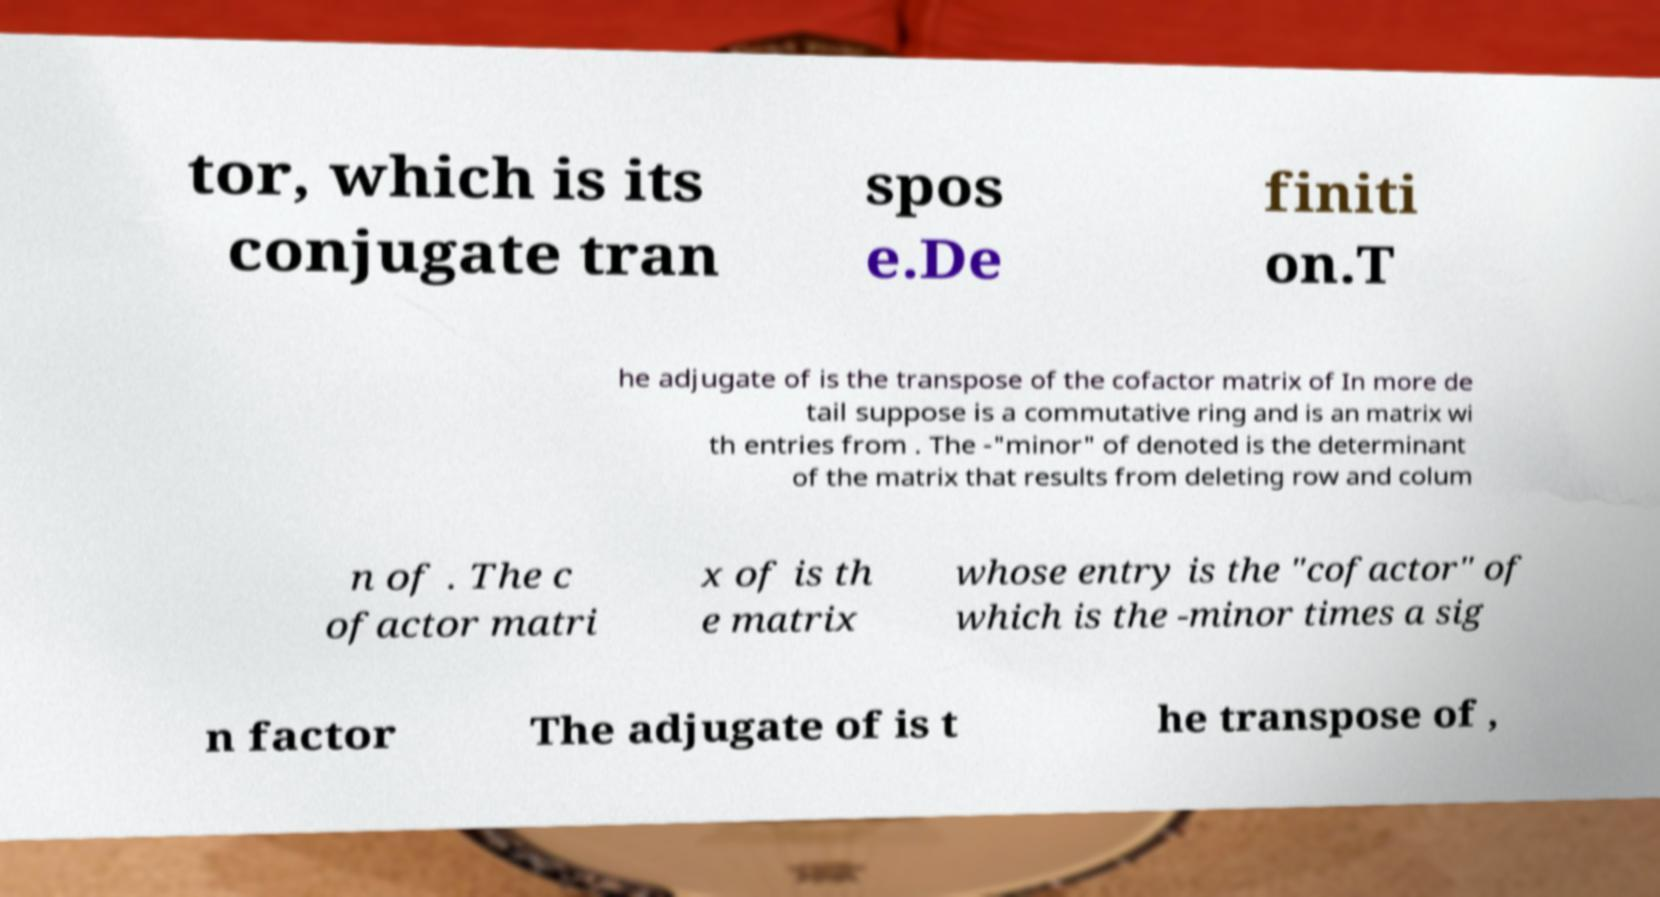Can you accurately transcribe the text from the provided image for me? tor, which is its conjugate tran spos e.De finiti on.T he adjugate of is the transpose of the cofactor matrix of In more de tail suppose is a commutative ring and is an matrix wi th entries from . The -"minor" of denoted is the determinant of the matrix that results from deleting row and colum n of . The c ofactor matri x of is th e matrix whose entry is the "cofactor" of which is the -minor times a sig n factor The adjugate of is t he transpose of , 